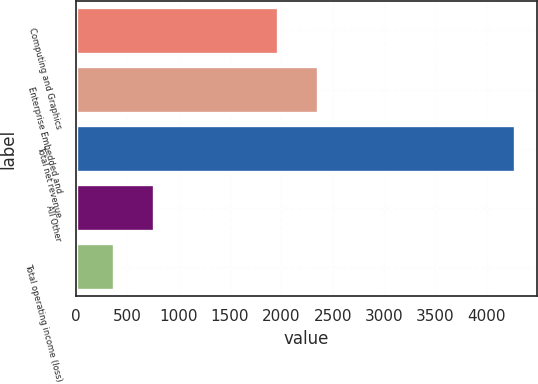Convert chart to OTSL. <chart><loc_0><loc_0><loc_500><loc_500><bar_chart><fcel>Computing and Graphics<fcel>Enterprise Embedded and<fcel>Total net revenue<fcel>All Other<fcel>Total operating income (loss)<nl><fcel>1967<fcel>2357<fcel>4272<fcel>762<fcel>372<nl></chart> 